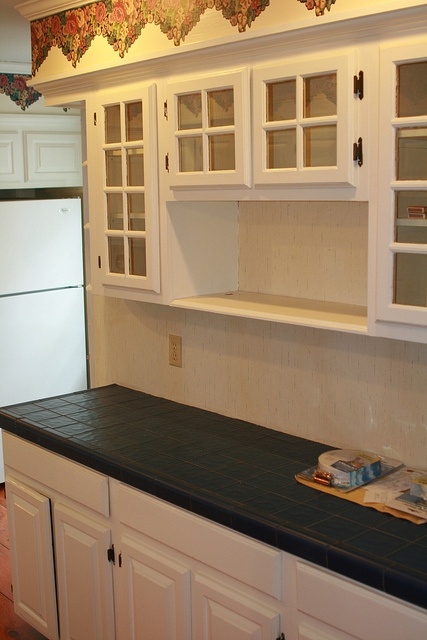Describe the objects in this image and their specific colors. I can see a refrigerator in gray, lightgray, darkgray, lightblue, and black tones in this image. 